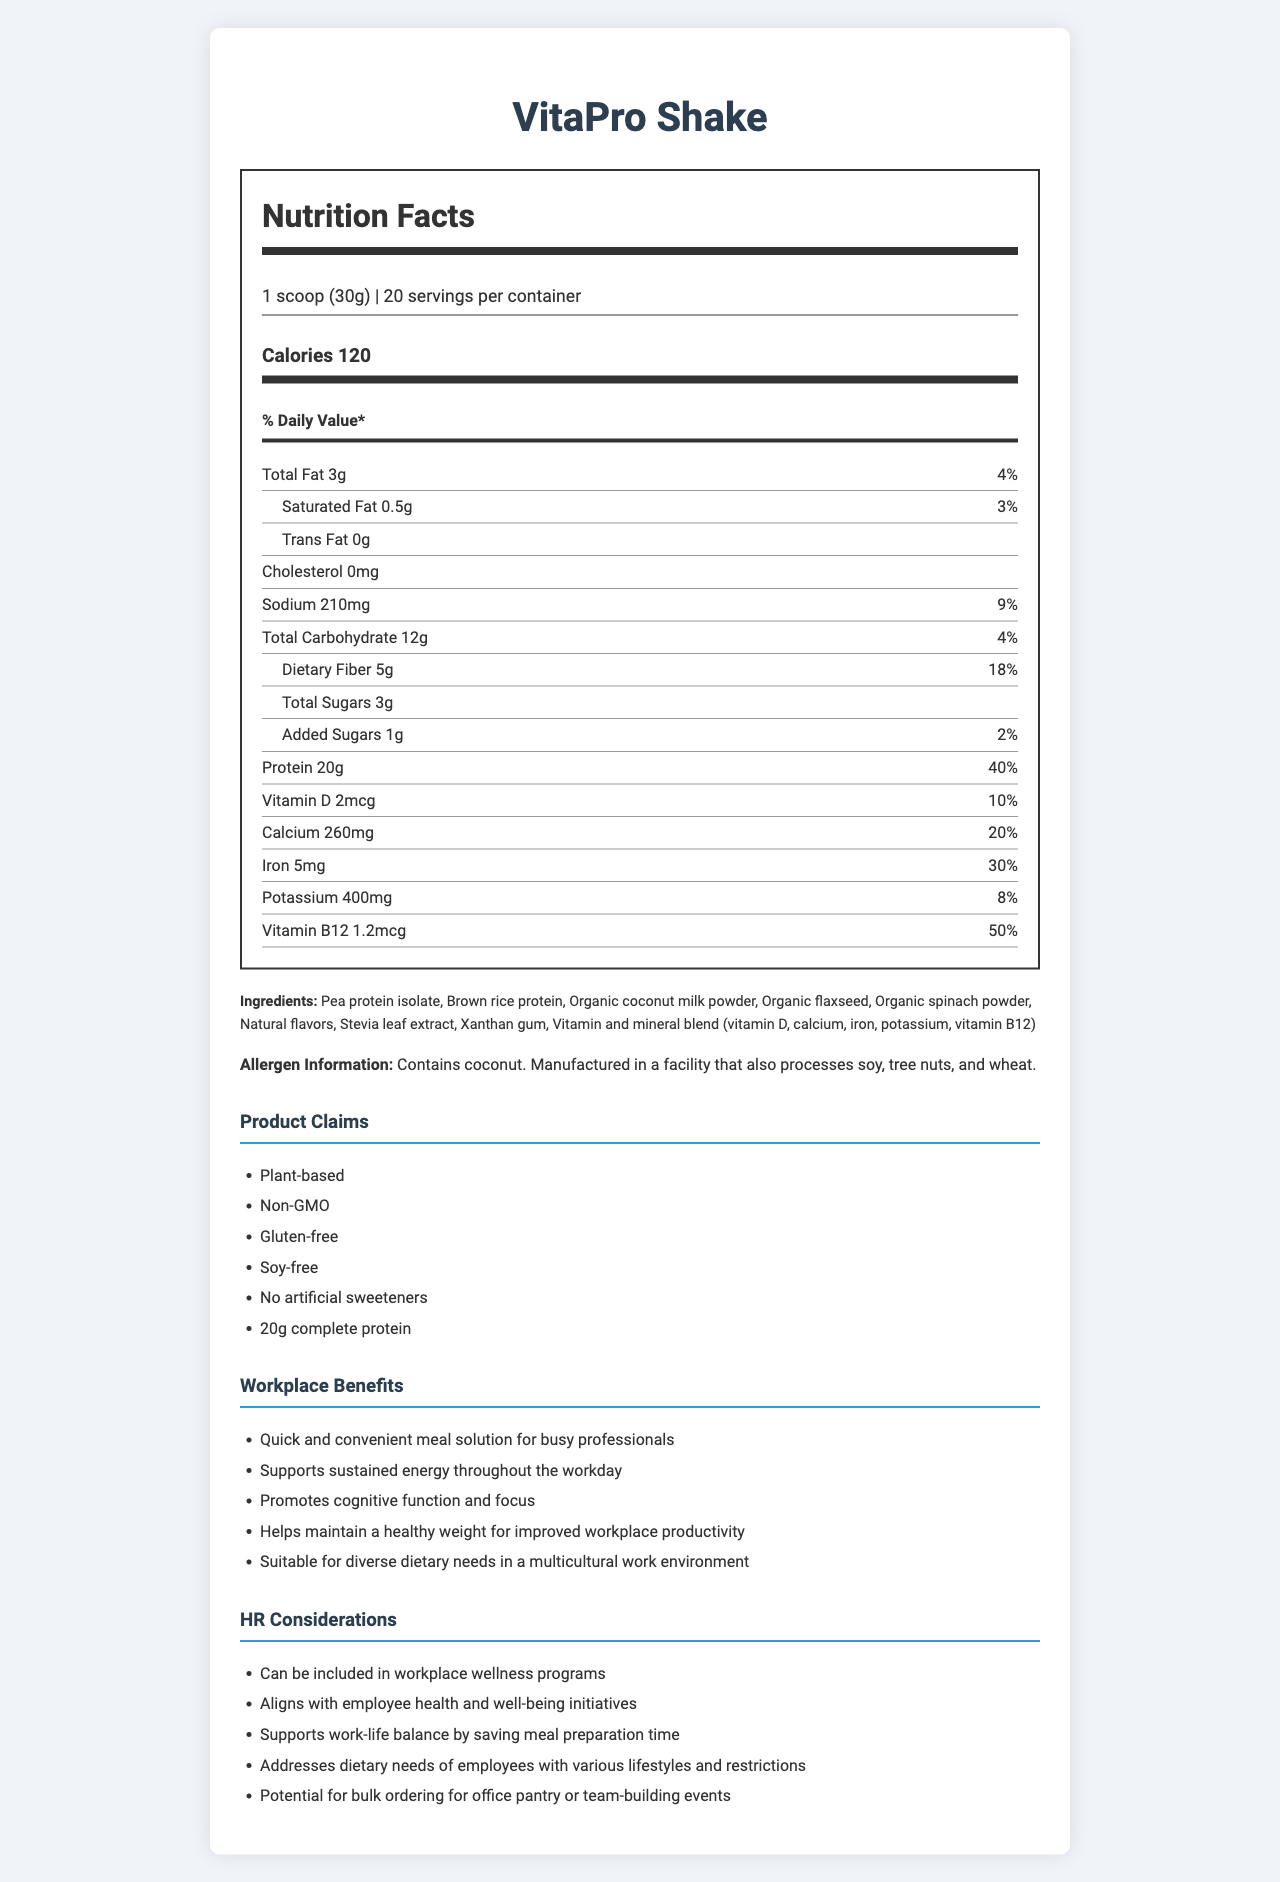what is the serving size of the VitaPro Shake? The serving size is indicated as "1 scoop (30g)" in the nutrition label.
Answer: 1 scoop (30g) how many servings are in one container of VitaPro Shake? The document states that there are 20 servings per container.
Answer: 20 how many calories are in one serving of VitaPro Shake? The document lists 120 calories per serving.
Answer: 120 what is the amount of protein in one serving of VitaPro Shake? It is mentioned that each serving of VitaPro Shake contains 20g of protein.
Answer: 20g what is the daily value percentage of iron in VitaPro Shake? The document shows that the daily value percentage of iron is 30%.
Answer: 30% how much dietary fiber does one serving of VitaPro Shake contain? The dietary fiber content is listed as 5g per serving.
Answer: 5g where is VitaPro Shake manufactured? The document does not provide information on the manufacturing location.
Answer: Not enough information how many grams of added sugars are in VitaPro Shake? The document indicates that there is 1g of added sugars per serving.
Answer: 1g which of the following vitamins has the highest daily value percentage in VitaPro Shake? A. Vitamin D B. Calcium C. Vitamin B12 D. Iron Vitamin B12 has a daily value percentage of 50%, which is the highest compared to Vitamin D (10%), Calcium (20%), and Iron (30%).
Answer: C. Vitamin B12 what are the main ingredients of VitaPro Shake? The document lists these as the main ingredients.
Answer: Pea protein isolate, Brown rice protein, Organic coconut milk powder, Organic flaxseed, Organic spinach powder, Natural flavors, Stevia leaf extract, Xanthan gum, Vitamin and mineral blend is VitaPro Shake gluten-free? The document claims that VitaPro Shake is gluten-free.
Answer: Yes describe the main purpose and key benefits of VitaPro Shake in the workplace. VitaPro Shake is intended to serve as a quick and convenient meal solution, especially for professionals with busy schedules. It supports sustained energy, cognitive function, and helps manage weight, making it useful for workplace productivity and wellness programs. Additionally, it addresses the dietary needs of diverse employees and can be ordered in bulk for office use.
Answer: VitaPro Shake is a plant-based meal replacement designed for busy professionals. It is quick and convenient, supports sustained energy, promotes cognitive function, and helps maintain a healthy weight. It is suitable for diverse dietary needs and can be included in workplace wellness programs. which of the following allergens is contained in VitaPro Shake? A. Soy B. Tree nuts C. Wheat D. Coconut The allergen information specifies that VitaPro Shake contains coconut.
Answer: D. Coconut what specific dietary needs does VitaPro Shake address? The document mentions that VitaPro Shake is suitable for diverse dietary needs.
Answer: Suitable for diverse dietary needs in a multicultural work environment 